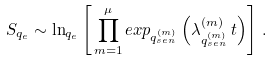<formula> <loc_0><loc_0><loc_500><loc_500>S _ { q _ { e } } \sim \ln _ { q _ { e } } \left [ \, \prod _ { m = 1 } ^ { \mu } e x p _ { q _ { s e n } ^ { ( m ) } } \left ( \lambda _ { q _ { s e n } ^ { ( m ) } } ^ { ( m ) } \, t \right ) \right ] \, .</formula> 